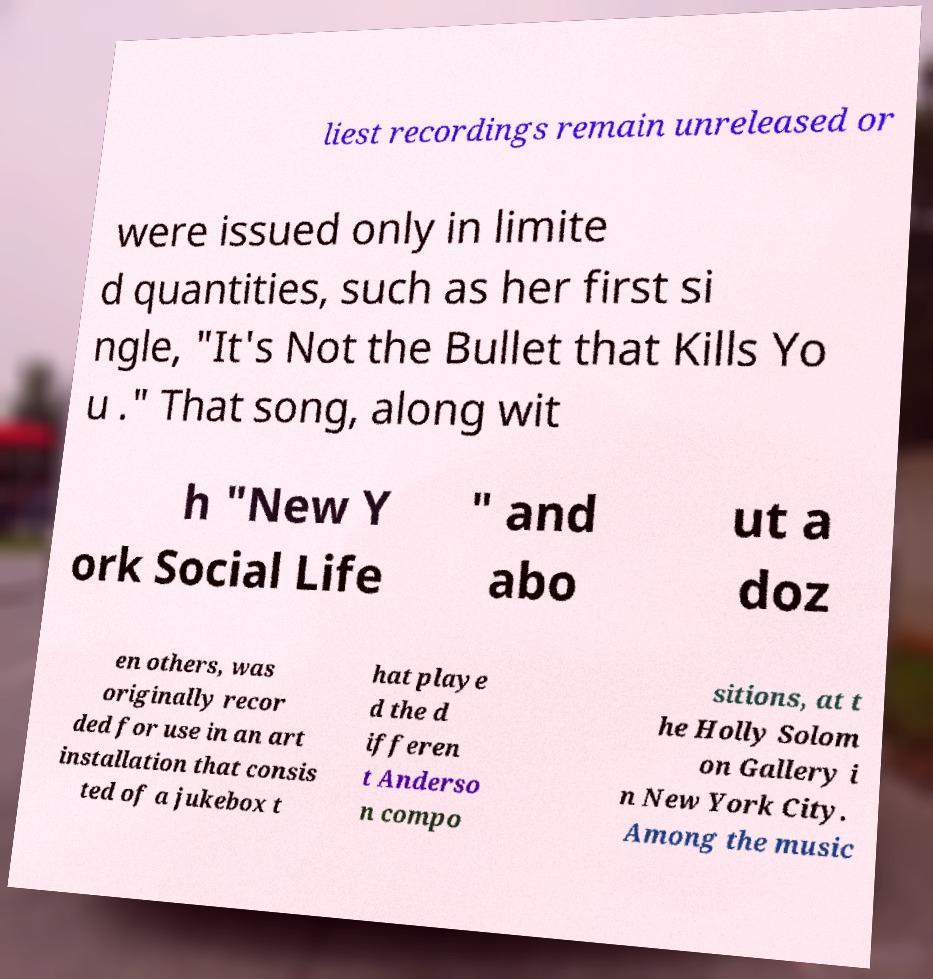Could you extract and type out the text from this image? liest recordings remain unreleased or were issued only in limite d quantities, such as her first si ngle, "It's Not the Bullet that Kills Yo u ." That song, along wit h "New Y ork Social Life " and abo ut a doz en others, was originally recor ded for use in an art installation that consis ted of a jukebox t hat playe d the d ifferen t Anderso n compo sitions, at t he Holly Solom on Gallery i n New York City. Among the music 